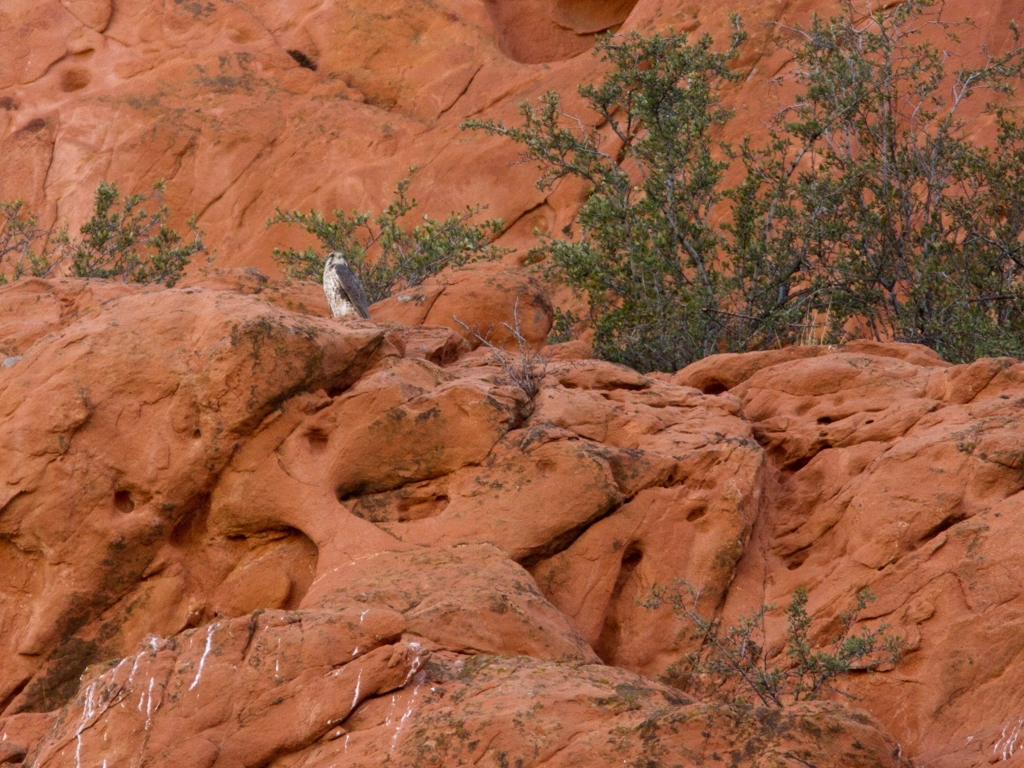Are there any notable weathering patterns on the rock formations? Yes, the rock formations in the image exhibit signs of erosion, as evidenced by the rounded shapes of the rocks and the grooves along their surfaces. These patterns are typically formed over long periods through the combined effects of wind, water, and temperature fluctuations. 